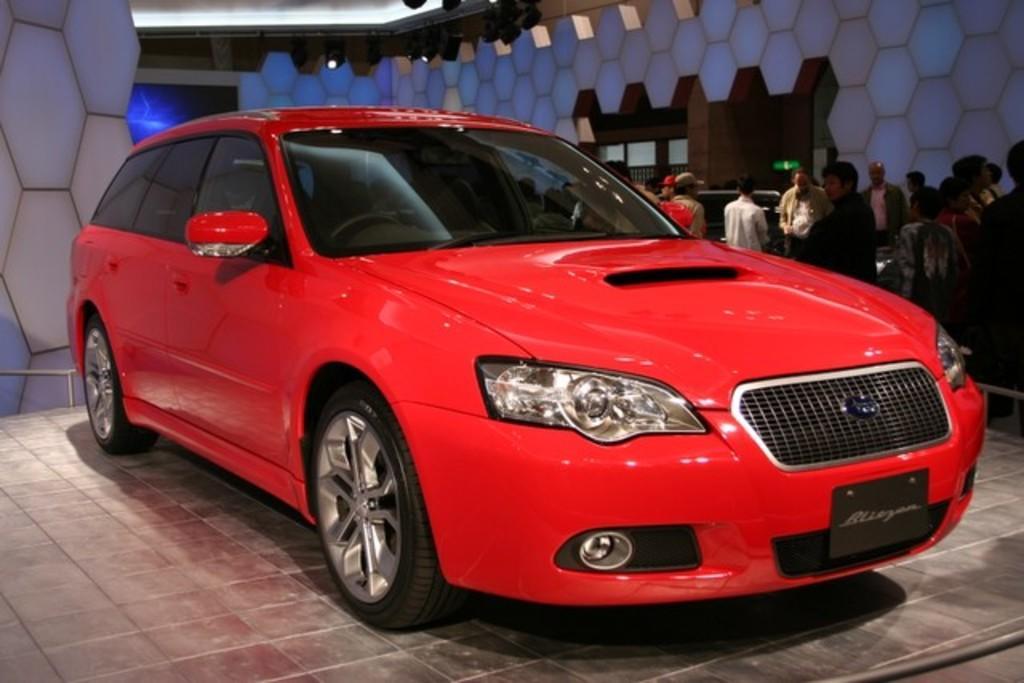Please provide a concise description of this image. In the center of the image there is a car on the floor. In the background there are persons, wall and lights. 